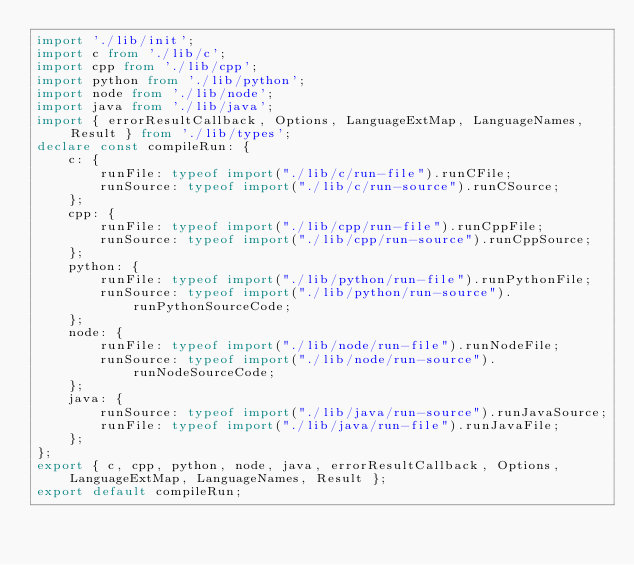Convert code to text. <code><loc_0><loc_0><loc_500><loc_500><_TypeScript_>import './lib/init';
import c from './lib/c';
import cpp from './lib/cpp';
import python from './lib/python';
import node from './lib/node';
import java from './lib/java';
import { errorResultCallback, Options, LanguageExtMap, LanguageNames, Result } from './lib/types';
declare const compileRun: {
    c: {
        runFile: typeof import("./lib/c/run-file").runCFile;
        runSource: typeof import("./lib/c/run-source").runCSource;
    };
    cpp: {
        runFile: typeof import("./lib/cpp/run-file").runCppFile;
        runSource: typeof import("./lib/cpp/run-source").runCppSource;
    };
    python: {
        runFile: typeof import("./lib/python/run-file").runPythonFile;
        runSource: typeof import("./lib/python/run-source").runPythonSourceCode;
    };
    node: {
        runFile: typeof import("./lib/node/run-file").runNodeFile;
        runSource: typeof import("./lib/node/run-source").runNodeSourceCode;
    };
    java: {
        runSource: typeof import("./lib/java/run-source").runJavaSource;
        runFile: typeof import("./lib/java/run-file").runJavaFile;
    };
};
export { c, cpp, python, node, java, errorResultCallback, Options, LanguageExtMap, LanguageNames, Result };
export default compileRun;
</code> 